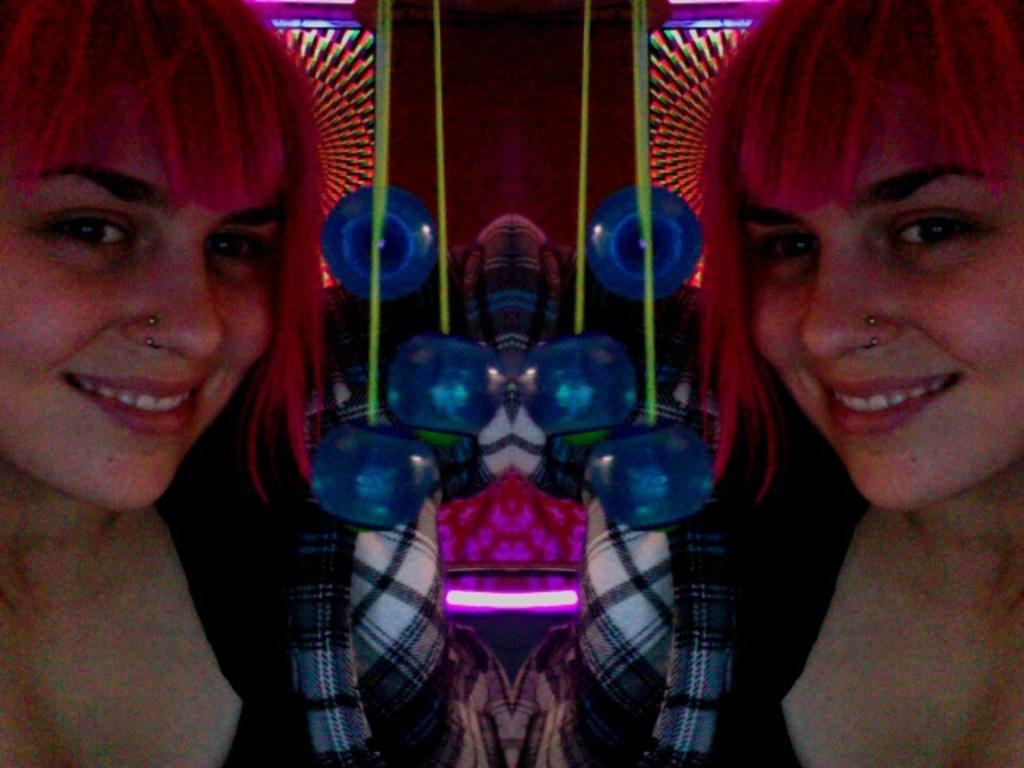In one or two sentences, can you explain what this image depicts? In this image we can see mirror reflection of same image on both sides. And there is a lady smiling. And we can see some other objects. And there are lights. 